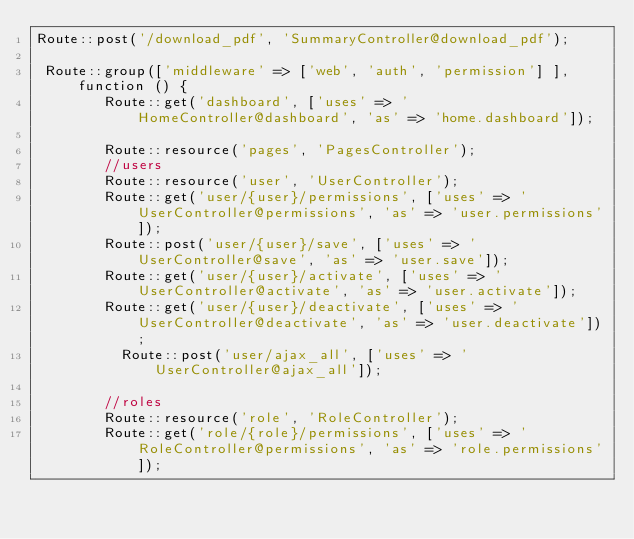<code> <loc_0><loc_0><loc_500><loc_500><_PHP_>Route::post('/download_pdf', 'SummaryController@download_pdf');

 Route::group(['middleware' => ['web', 'auth', 'permission'] ], function () {
        Route::get('dashboard', ['uses' => 'HomeController@dashboard', 'as' => 'home.dashboard']);

        Route::resource('pages', 'PagesController');
        //users
        Route::resource('user', 'UserController');
        Route::get('user/{user}/permissions', ['uses' => 'UserController@permissions', 'as' => 'user.permissions']);
        Route::post('user/{user}/save', ['uses' => 'UserController@save', 'as' => 'user.save']);
        Route::get('user/{user}/activate', ['uses' => 'UserController@activate', 'as' => 'user.activate']);
        Route::get('user/{user}/deactivate', ['uses' => 'UserController@deactivate', 'as' => 'user.deactivate']);
          Route::post('user/ajax_all', ['uses' => 'UserController@ajax_all']);

        //roles
        Route::resource('role', 'RoleController');
        Route::get('role/{role}/permissions', ['uses' => 'RoleController@permissions', 'as' => 'role.permissions']);</code> 